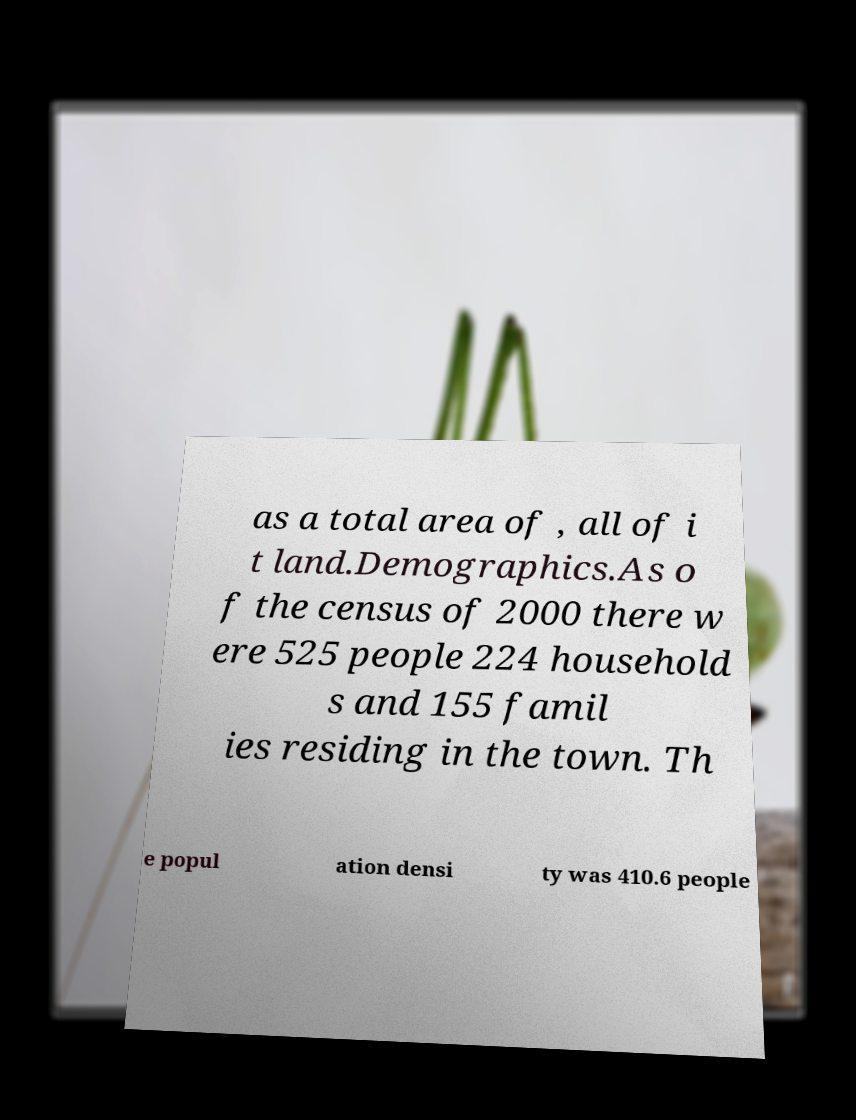What messages or text are displayed in this image? I need them in a readable, typed format. as a total area of , all of i t land.Demographics.As o f the census of 2000 there w ere 525 people 224 household s and 155 famil ies residing in the town. Th e popul ation densi ty was 410.6 people 